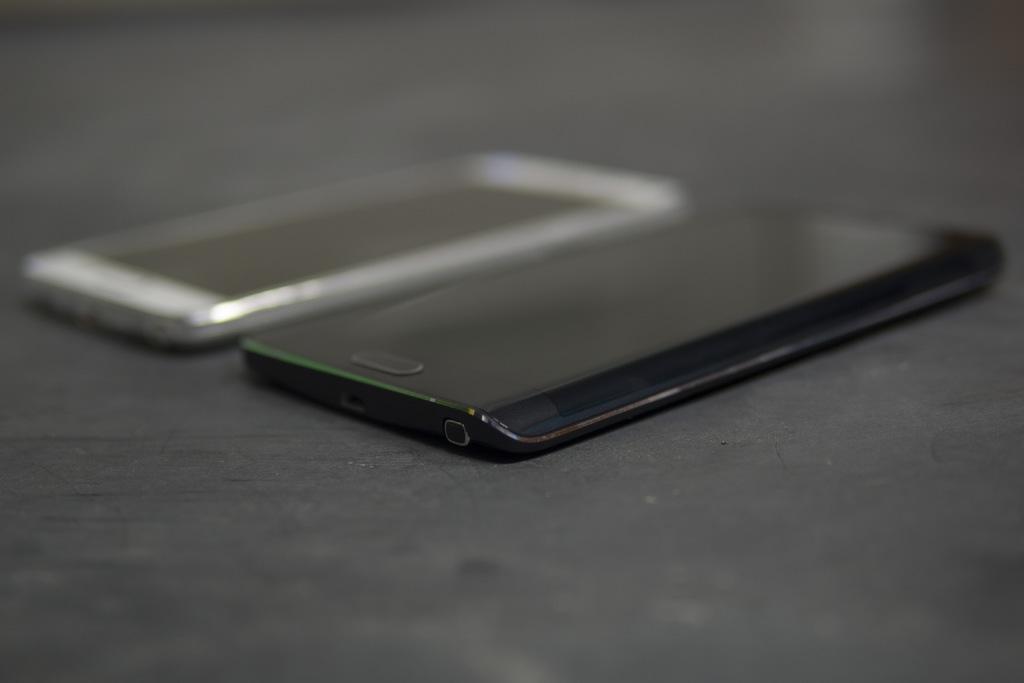Describe this image in one or two sentences. In this image, I can see two mobile phones. One is white and the other one is black in color. This is the home button. 